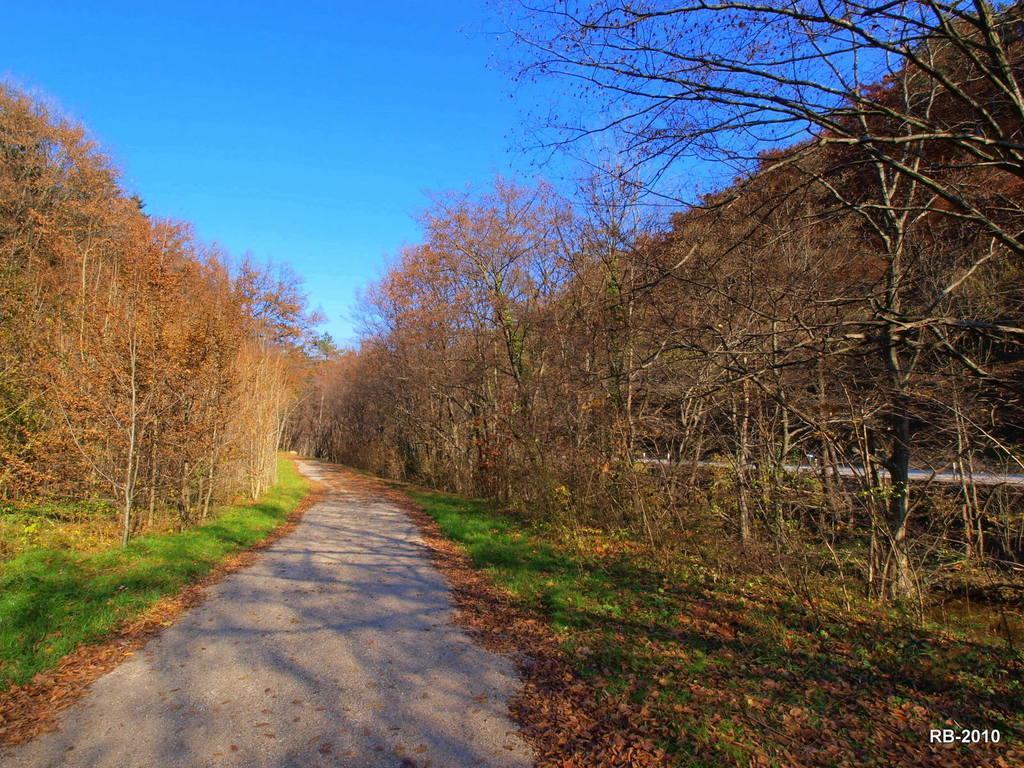Could you give a brief overview of what you see in this image? In this image we can see the trees, grass, dried leaves and also the path. We can also see the sky. In the bottom right corner we can see the alphabets and also the numbers. 